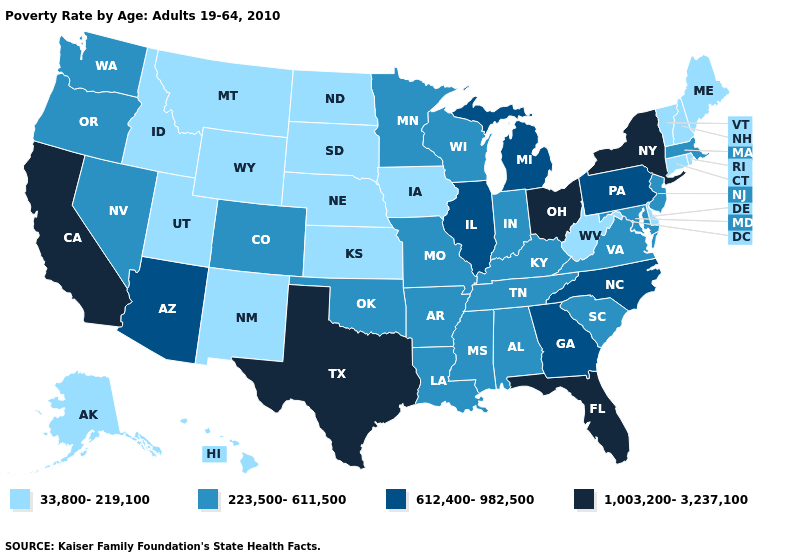Does Mississippi have the same value as Wisconsin?
Concise answer only. Yes. Which states have the lowest value in the South?
Write a very short answer. Delaware, West Virginia. What is the value of Hawaii?
Write a very short answer. 33,800-219,100. Does Virginia have the same value as Washington?
Keep it brief. Yes. Which states hav the highest value in the South?
Keep it brief. Florida, Texas. Does Hawaii have a lower value than Montana?
Give a very brief answer. No. Which states hav the highest value in the Northeast?
Write a very short answer. New York. What is the lowest value in the Northeast?
Write a very short answer. 33,800-219,100. What is the value of Maine?
Keep it brief. 33,800-219,100. Does Massachusetts have a higher value than New York?
Write a very short answer. No. What is the value of West Virginia?
Keep it brief. 33,800-219,100. Name the states that have a value in the range 33,800-219,100?
Concise answer only. Alaska, Connecticut, Delaware, Hawaii, Idaho, Iowa, Kansas, Maine, Montana, Nebraska, New Hampshire, New Mexico, North Dakota, Rhode Island, South Dakota, Utah, Vermont, West Virginia, Wyoming. What is the value of Mississippi?
Keep it brief. 223,500-611,500. Name the states that have a value in the range 33,800-219,100?
Short answer required. Alaska, Connecticut, Delaware, Hawaii, Idaho, Iowa, Kansas, Maine, Montana, Nebraska, New Hampshire, New Mexico, North Dakota, Rhode Island, South Dakota, Utah, Vermont, West Virginia, Wyoming. Name the states that have a value in the range 1,003,200-3,237,100?
Quick response, please. California, Florida, New York, Ohio, Texas. 